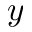<formula> <loc_0><loc_0><loc_500><loc_500>y</formula> 